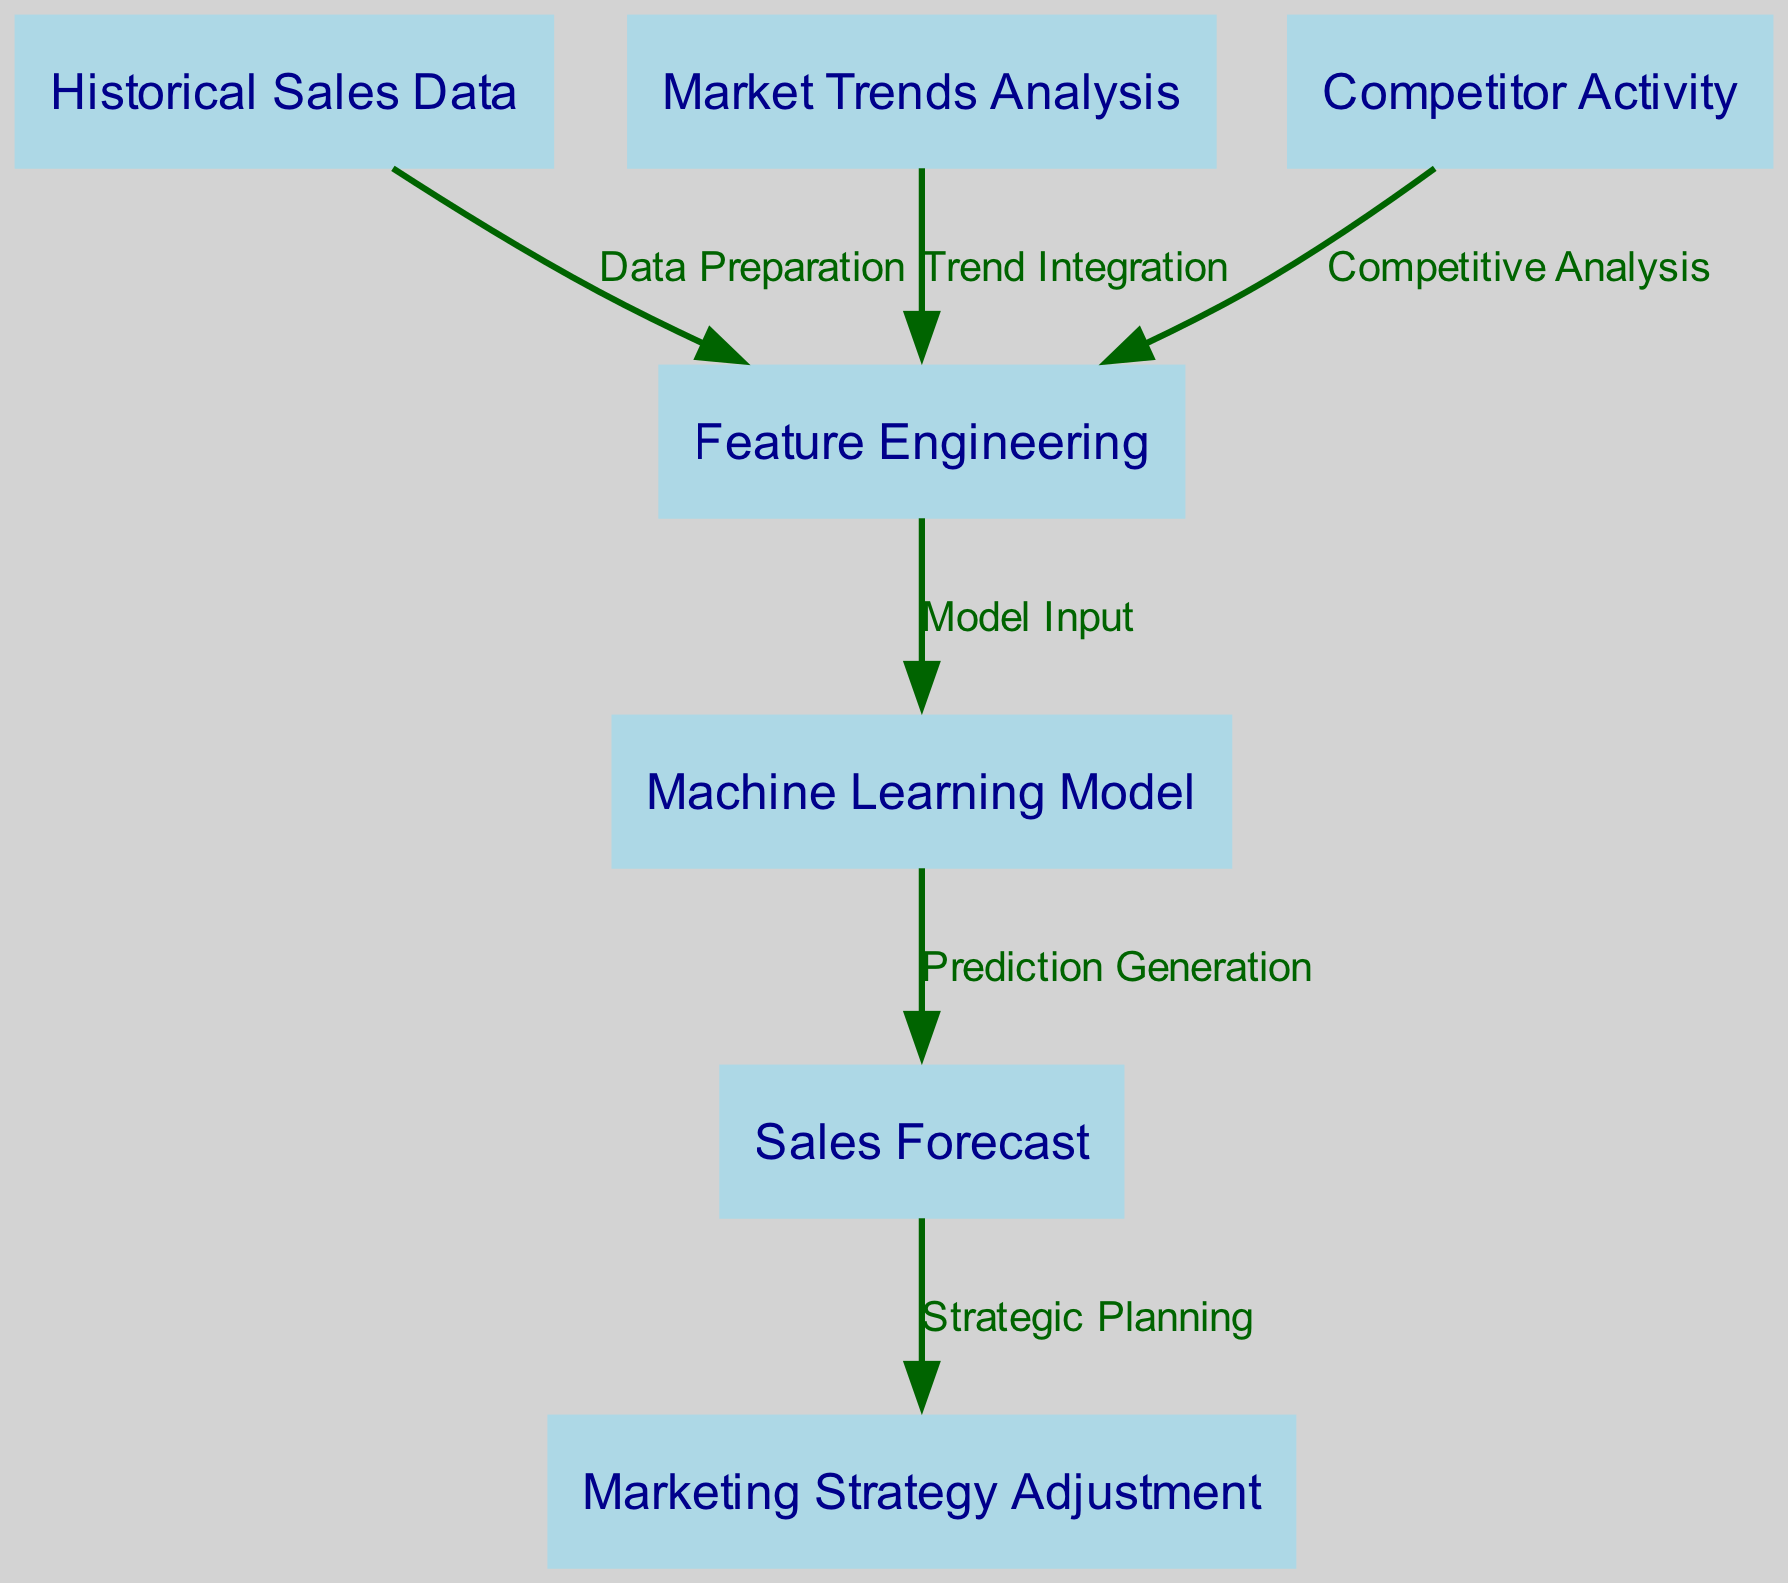What is the starting node of the diagram? The diagram starts with the node labeled "Historical Sales Data". This is the first element in the flowchart, indicating the beginning of the predictive analytics process.
Answer: Historical Sales Data How many nodes are in the diagram? There are a total of seven nodes within the diagram, each representing a different step or data element involved in the sales forecasting process.
Answer: 7 What is the final output of the flowchart? The final output of the flowchart is "Sales Forecast", which is generated as a result of the machine learning model processing the input data.
Answer: Sales Forecast Which node is connected to "Feature Engineering"? The "Feature Engineering" node is connected to the node labeled "Machine Learning Model". This indicates that the outputs from feature engineering serve as inputs to the machine learning model.
Answer: Machine Learning Model What type of analysis leads into "Feature Engineering"? "Market Trends Analysis", "Competitor Activity", and "Historical Sales Data" all lead into "Feature Engineering" as they provide critical information that is integrated to prepare data for modeling.
Answer: Market Trends Analysis, Competitor Activity, Historical Sales Data What action follows "Sales Forecast" in the diagram? After the "Sales Forecast" node, the next action shown in the flowchart is "Marketing Strategy Adjustment", indicating that forecasting informs marketing strategy planning.
Answer: Marketing Strategy Adjustment Which nodes contribute to the “Model Input”? The nodes contributing to "Model Input" are "Historical Sales Data", "Market Trends Analysis", and "Competitor Activity". Each of these provides necessary data for building the model.
Answer: Historical Sales Data, Market Trends Analysis, Competitor Activity What is the relationship between "Machine Learning Model" and "Sales Forecast"? The relationship is that the "Machine Learning Model" generates the "Sales Forecast", meaning that the model processes the input data to predict future sales trends.
Answer: Prediction Generation 